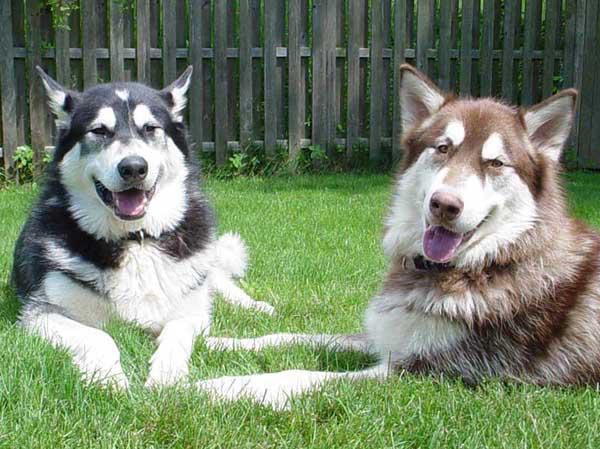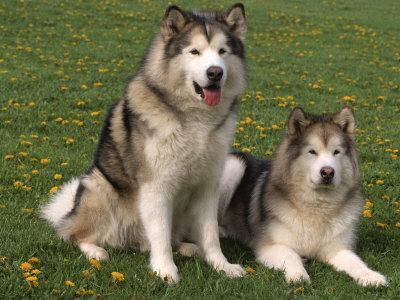The first image is the image on the left, the second image is the image on the right. For the images shown, is this caption "The left and right images contain pairs of husky dogs in the snow, and at least some dogs are 'hitched' with ropes." true? Answer yes or no. No. The first image is the image on the left, the second image is the image on the right. Assess this claim about the two images: "The left image contains two dogs surrounded by snow.". Correct or not? Answer yes or no. No. 